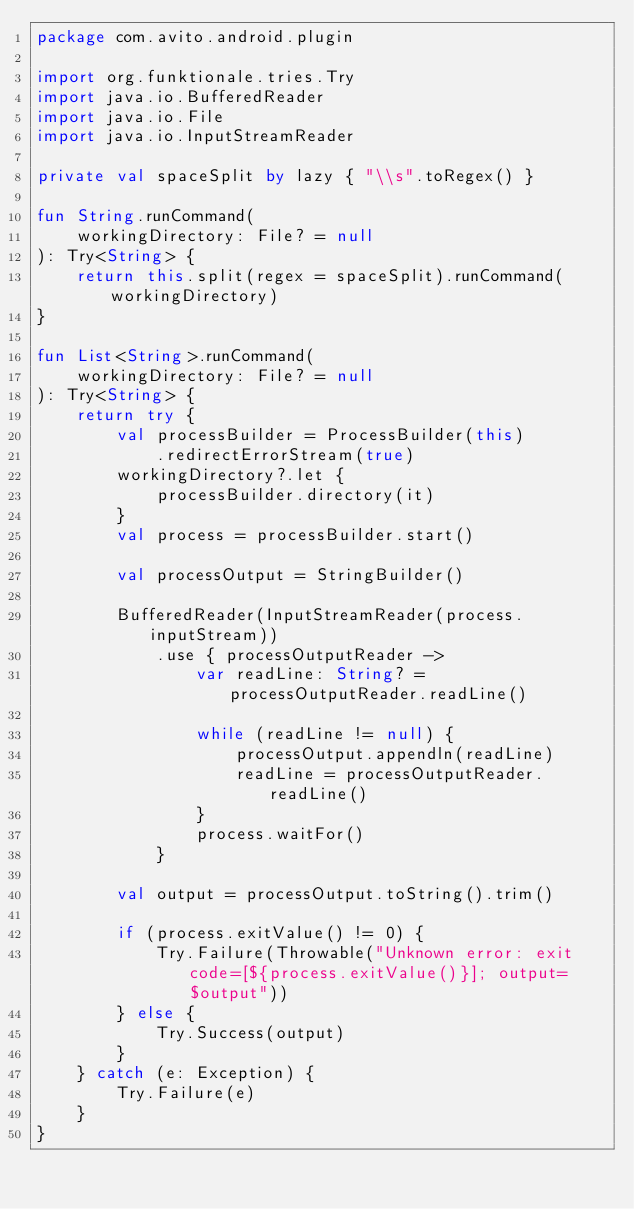Convert code to text. <code><loc_0><loc_0><loc_500><loc_500><_Kotlin_>package com.avito.android.plugin

import org.funktionale.tries.Try
import java.io.BufferedReader
import java.io.File
import java.io.InputStreamReader

private val spaceSplit by lazy { "\\s".toRegex() }

fun String.runCommand(
    workingDirectory: File? = null
): Try<String> {
    return this.split(regex = spaceSplit).runCommand(workingDirectory)
}

fun List<String>.runCommand(
    workingDirectory: File? = null
): Try<String> {
    return try {
        val processBuilder = ProcessBuilder(this)
            .redirectErrorStream(true)
        workingDirectory?.let {
            processBuilder.directory(it)
        }
        val process = processBuilder.start()

        val processOutput = StringBuilder()

        BufferedReader(InputStreamReader(process.inputStream))
            .use { processOutputReader ->
                var readLine: String? = processOutputReader.readLine()

                while (readLine != null) {
                    processOutput.appendln(readLine)
                    readLine = processOutputReader.readLine()
                }
                process.waitFor()
            }

        val output = processOutput.toString().trim()

        if (process.exitValue() != 0) {
            Try.Failure(Throwable("Unknown error: exit code=[${process.exitValue()}]; output=$output"))
        } else {
            Try.Success(output)
        }
    } catch (e: Exception) {
        Try.Failure(e)
    }
}
</code> 